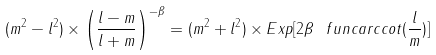Convert formula to latex. <formula><loc_0><loc_0><loc_500><loc_500>( m ^ { 2 } - l ^ { 2 } ) \times \left ( \frac { l - m } { l + m } \right ) ^ { - \beta } = ( m ^ { 2 } + l ^ { 2 } ) \times E x p [ 2 \beta \ f u n c { a r c c o t } ( \frac { l } { m } ) ]</formula> 